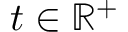<formula> <loc_0><loc_0><loc_500><loc_500>t \in \mathbb { R } ^ { + }</formula> 